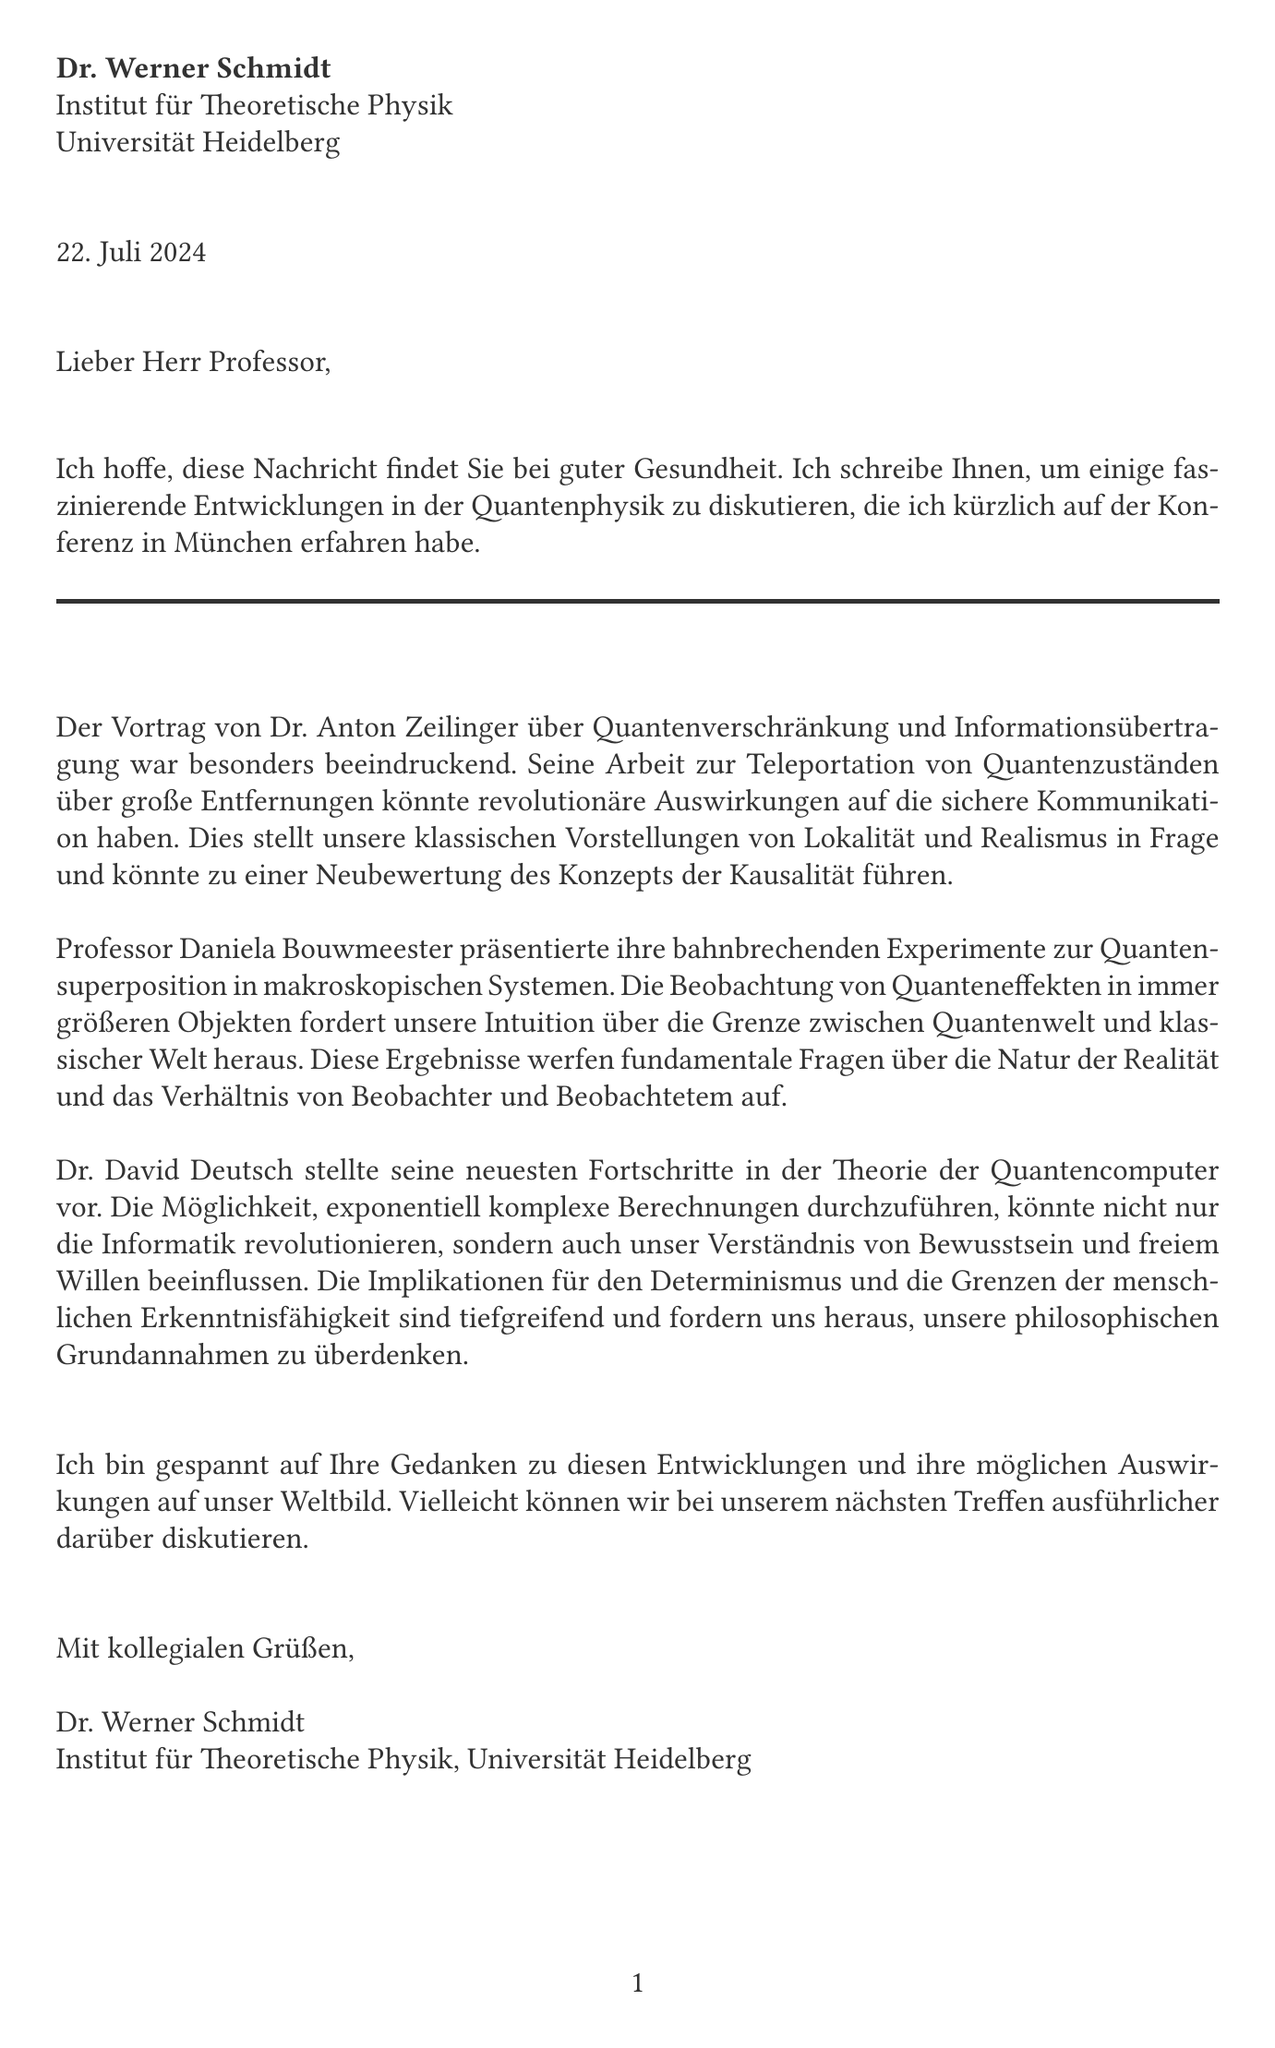Was ist der Titel des Vortrags von Dr. Anton Zeilinger? Der Titel des Vortrags von Dr. Anton Zeilinger ist über Quantenverschränkung und Informationsübertragung.
Answer: Quantenverschränkung und Informationsübertragung Was ist das Hauptthema von Professor Daniela Bouwmeester's Präsentation? Das Hauptthema von Professor Daniela Bouwmeester's Präsentation sind Experimente zur Quantensuperposition in makroskopischen Systemen.
Answer: Quantensuperposition in makroskopischen Systemen Wie nennt man die Theorie, die Dr. David Deutsch präsentiert? Die Theorie, die Dr. David Deutsch präsentiert, bezieht sich auf Quantencomputer.
Answer: Quantencomputer Welcher Wissenschaftler ist bekannt für seine Pionierarbeit in Quantenteleportation und Verschränkung? Der Wissenschaftler, der bekannt ist für seine Pionierarbeit in Quantenteleportation und Verschränkung, ist Anton Zeilinger.
Answer: Anton Zeilinger Was wird in der Korrespondenz in Bezug auf die sichere Kommunikation erwähnt? In der Korrespondenz wird erwähnt, dass Dr. Zeilingers Arbeit zur Teleportation von Quantenzuständen über große Entfernungen revolutionäre Auswirkungen auf die sichere Kommunikation haben könnte.
Answer: revolutionäre Auswirkungen auf die sichere Kommunikation Was wird als eine mögliche Auswirkung von Quantencomputern genannt? Eine mögliche Auswirkung von Quantencomputern, die genannt wird, ist das Verständnis von Bewusstsein und freiem Willen.
Answer: Verständnis von Bewusstsein und freiem Willen Was könnte aufgrund der neuesten Fortschritte in der Quantenphysik in Frage gestellt werden? Aufgrund der neuesten Fortschritte in der Quantenphysik könnte der klassische Realismus in Frage gestellt werden.
Answer: klassischer Realismus Wann und wo fand die besprochene Konferenz statt? Die Konferenz fand kürzlich in München statt.
Answer: München 